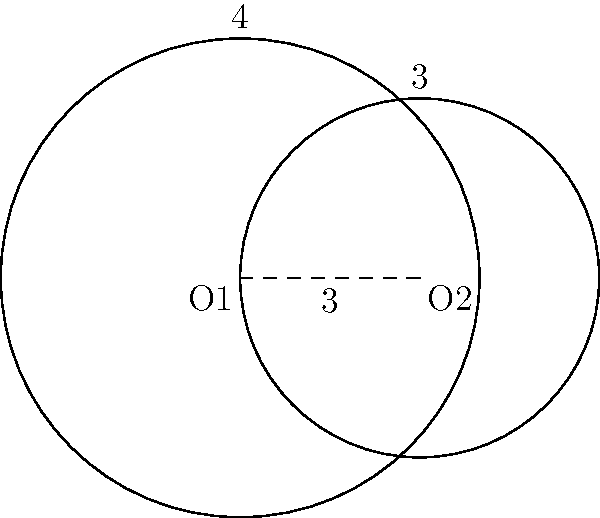In a 2D game map, two circular power-up zones are represented by the circles shown. The larger circle has a radius of 4 units, and the smaller circle has a radius of 3 units. The centers of the circles are 3 units apart. Calculate the area of the overlapping region where both power-ups are active simultaneously. To find the area of overlap between two circles, we'll use the following steps:

1) First, we need to calculate the angle $\theta$ at the center of each circle formed by the line joining the centers and the line to the intersection point.

   For circle 1: $\cos(\theta_1) = \frac{d^2 + r_1^2 - r_2^2}{2dr_1}$
   For circle 2: $\cos(\theta_2) = \frac{d^2 + r_2^2 - r_1^2}{2dr_2}$

   Where $d$ is the distance between centers, $r_1$ and $r_2$ are the radii.

2) $\theta_1 = \arccos(\frac{3^2 + 4^2 - 3^2}{2 * 3 * 4}) = \arccos(\frac{13}{24}) \approx 0.9272$ radians
   $\theta_2 = \arccos(\frac{3^2 + 3^2 - 4^2}{2 * 3 * 3}) = \arccos(\frac{1}{6}) \approx 1.5708$ radians

3) The area of overlap is the sum of two circular sectors minus the area of two triangles:

   $A = r_1^2\theta_1 + r_2^2\theta_2 - (r_1^2\sin(\theta_1) + r_2^2\sin(\theta_2))$

4) Substituting the values:
   $A = 4^2 * 0.9272 + 3^2 * 1.5708 - (4^2 * \sin(0.9272) + 3^2 * \sin(1.5708))$
   $A = 14.8352 + 14.1372 - (13.9080 + 9)$
   $A = 28.9724 - 22.9080 = 6.0644$ square units

5) Rounding to two decimal places: 6.06 square units
Answer: 6.06 square units 